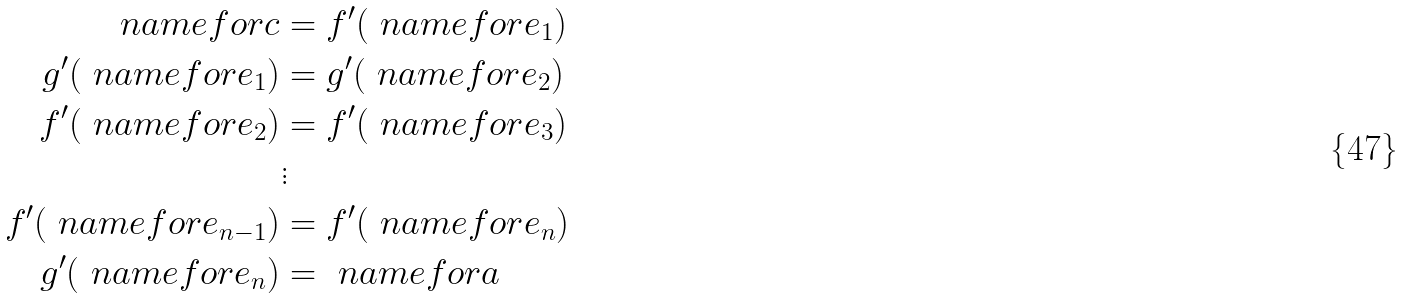<formula> <loc_0><loc_0><loc_500><loc_500>\ n a m e f o r { c } & = f ^ { \prime } ( \ n a m e f o r { e _ { 1 } } ) \\ g ^ { \prime } ( \ n a m e f o r { e _ { 1 } } ) & = g ^ { \prime } ( \ n a m e f o r { e _ { 2 } } ) \\ f ^ { \prime } ( \ n a m e f o r { e _ { 2 } } ) & = f ^ { \prime } ( \ n a m e f o r { e _ { 3 } } ) \\ & \vdots \\ f ^ { \prime } ( \ n a m e f o r { e _ { n - 1 } } ) & = f ^ { \prime } ( \ n a m e f o r { e _ { n } } ) \\ g ^ { \prime } ( \ n a m e f o r { e _ { n } } ) & = \ n a m e f o r { a }</formula> 